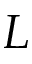<formula> <loc_0><loc_0><loc_500><loc_500>L</formula> 